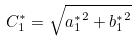<formula> <loc_0><loc_0><loc_500><loc_500>C _ { 1 } ^ { * } = \sqrt { { a _ { 1 } ^ { * } } ^ { 2 } + { b _ { 1 } ^ { * } } ^ { 2 } }</formula> 